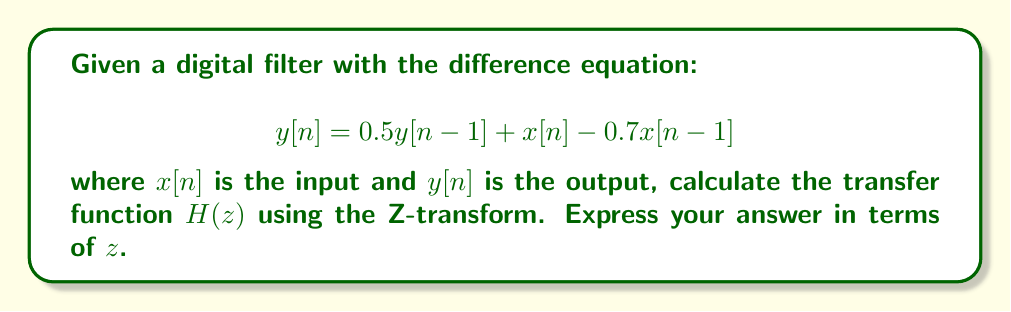Solve this math problem. To find the transfer function $H(z)$ using the Z-transform, we follow these steps:

1) Take the Z-transform of both sides of the difference equation:
   $$Z\{y[n]\} = Z\{0.5y[n-1] + x[n] - 0.7x[n-1]\}$$

2) Use the linearity property and the time-shift property of the Z-transform:
   $$Y(z) = 0.5z^{-1}Y(z) + X(z) - 0.7z^{-1}X(z)$$

3) Group terms with $Y(z)$ on the left side and terms with $X(z)$ on the right side:
   $$Y(z) - 0.5z^{-1}Y(z) = X(z) - 0.7z^{-1}X(z)$$

4) Factor out $Y(z)$ and $X(z)$:
   $$Y(z)(1 - 0.5z^{-1}) = X(z)(1 - 0.7z^{-1})$$

5) The transfer function $H(z)$ is defined as the ratio of output to input in the Z-domain:
   $$H(z) = \frac{Y(z)}{X(z)} = \frac{1 - 0.7z^{-1}}{1 - 0.5z^{-1}}$$

6) Multiply both numerator and denominator by $z$ to express in positive powers of $z$:
   $$H(z) = \frac{z - 0.7}{z - 0.5}$$

This is the transfer function of the given digital filter.
Answer: $$H(z) = \frac{z - 0.7}{z - 0.5}$$ 